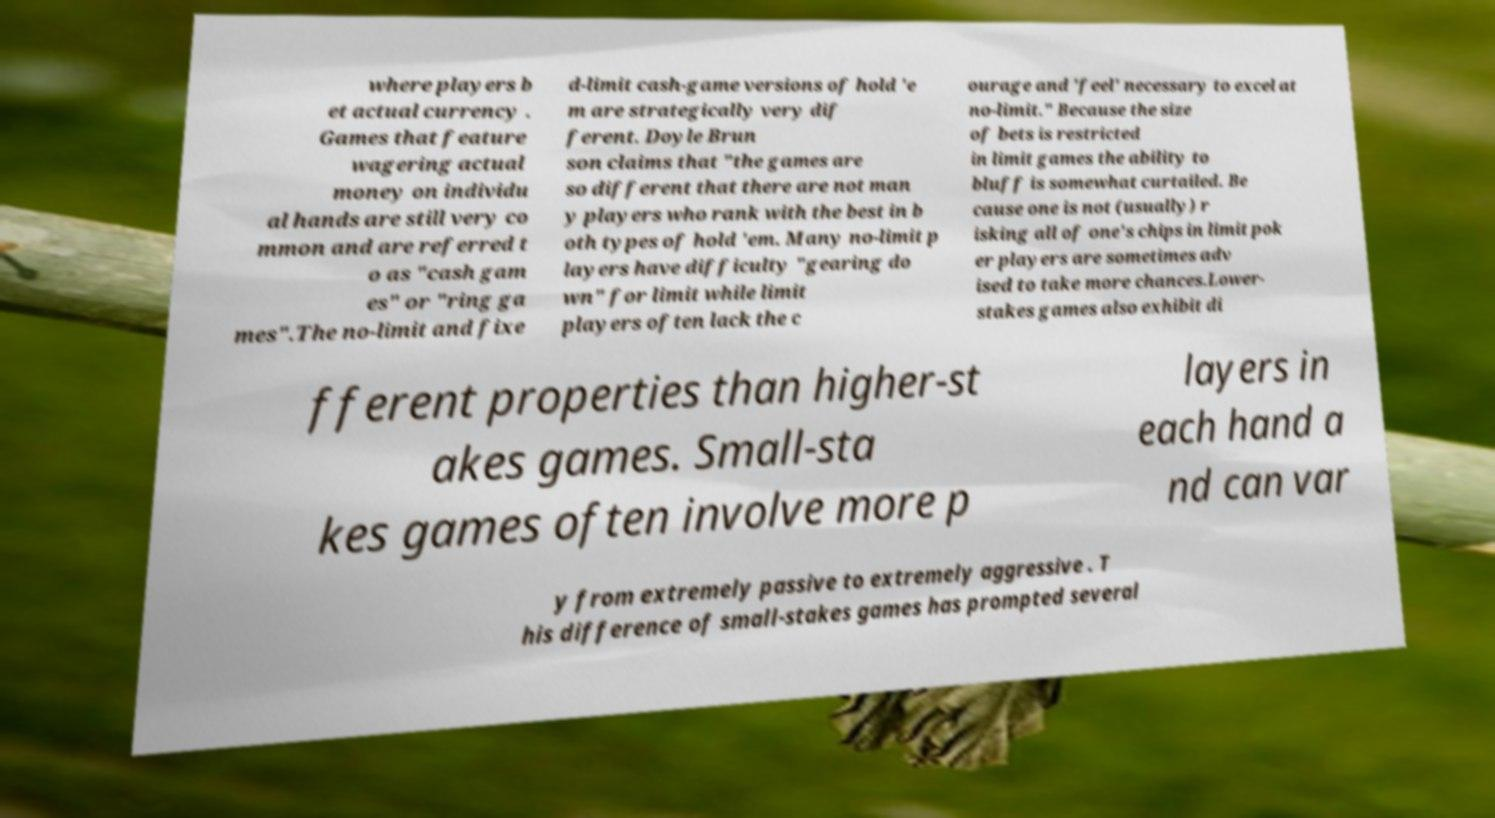Could you assist in decoding the text presented in this image and type it out clearly? where players b et actual currency . Games that feature wagering actual money on individu al hands are still very co mmon and are referred t o as "cash gam es" or "ring ga mes".The no-limit and fixe d-limit cash-game versions of hold 'e m are strategically very dif ferent. Doyle Brun son claims that "the games are so different that there are not man y players who rank with the best in b oth types of hold 'em. Many no-limit p layers have difficulty "gearing do wn" for limit while limit players often lack the c ourage and 'feel' necessary to excel at no-limit." Because the size of bets is restricted in limit games the ability to bluff is somewhat curtailed. Be cause one is not (usually) r isking all of one's chips in limit pok er players are sometimes adv ised to take more chances.Lower- stakes games also exhibit di fferent properties than higher-st akes games. Small-sta kes games often involve more p layers in each hand a nd can var y from extremely passive to extremely aggressive . T his difference of small-stakes games has prompted several 